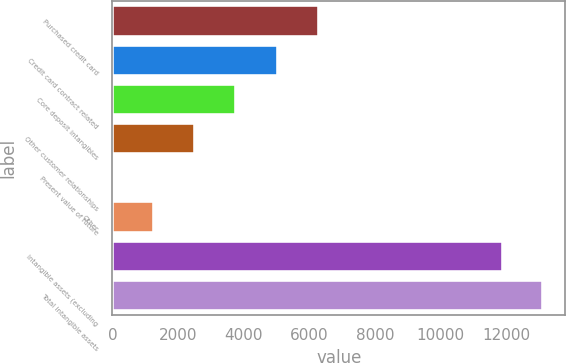Convert chart. <chart><loc_0><loc_0><loc_500><loc_500><bar_chart><fcel>Purchased credit card<fcel>Credit card contract related<fcel>Core deposit intangibles<fcel>Other customer relationships<fcel>Present value of future<fcel>Other<fcel>Intangible assets (excluding<fcel>Total intangible assets<nl><fcel>6287<fcel>5045<fcel>3758<fcel>2516<fcel>32<fcel>1274<fcel>11894<fcel>13136<nl></chart> 